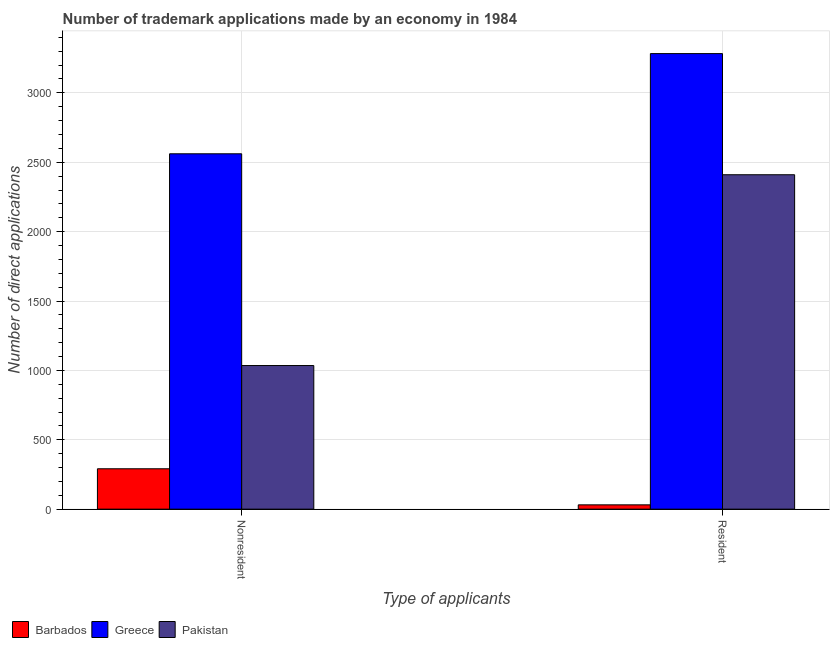How many different coloured bars are there?
Your answer should be compact. 3. Are the number of bars on each tick of the X-axis equal?
Your answer should be compact. Yes. How many bars are there on the 2nd tick from the left?
Give a very brief answer. 3. What is the label of the 2nd group of bars from the left?
Your answer should be very brief. Resident. What is the number of trademark applications made by non residents in Barbados?
Offer a terse response. 291. Across all countries, what is the maximum number of trademark applications made by non residents?
Offer a terse response. 2561. Across all countries, what is the minimum number of trademark applications made by residents?
Provide a short and direct response. 31. In which country was the number of trademark applications made by residents minimum?
Offer a very short reply. Barbados. What is the total number of trademark applications made by residents in the graph?
Make the answer very short. 5724. What is the difference between the number of trademark applications made by non residents in Greece and that in Pakistan?
Make the answer very short. 1526. What is the difference between the number of trademark applications made by non residents in Pakistan and the number of trademark applications made by residents in Greece?
Your answer should be very brief. -2248. What is the average number of trademark applications made by residents per country?
Your answer should be compact. 1908. What is the difference between the number of trademark applications made by non residents and number of trademark applications made by residents in Greece?
Offer a very short reply. -722. In how many countries, is the number of trademark applications made by non residents greater than 1400 ?
Keep it short and to the point. 1. What is the ratio of the number of trademark applications made by residents in Greece to that in Pakistan?
Provide a succinct answer. 1.36. In how many countries, is the number of trademark applications made by residents greater than the average number of trademark applications made by residents taken over all countries?
Ensure brevity in your answer.  2. What does the 3rd bar from the right in Nonresident represents?
Make the answer very short. Barbados. How many countries are there in the graph?
Provide a short and direct response. 3. What is the difference between two consecutive major ticks on the Y-axis?
Offer a very short reply. 500. How are the legend labels stacked?
Make the answer very short. Horizontal. What is the title of the graph?
Your response must be concise. Number of trademark applications made by an economy in 1984. What is the label or title of the X-axis?
Your answer should be very brief. Type of applicants. What is the label or title of the Y-axis?
Ensure brevity in your answer.  Number of direct applications. What is the Number of direct applications of Barbados in Nonresident?
Give a very brief answer. 291. What is the Number of direct applications in Greece in Nonresident?
Your answer should be compact. 2561. What is the Number of direct applications in Pakistan in Nonresident?
Keep it short and to the point. 1035. What is the Number of direct applications of Barbados in Resident?
Give a very brief answer. 31. What is the Number of direct applications of Greece in Resident?
Your answer should be very brief. 3283. What is the Number of direct applications of Pakistan in Resident?
Give a very brief answer. 2410. Across all Type of applicants, what is the maximum Number of direct applications in Barbados?
Offer a very short reply. 291. Across all Type of applicants, what is the maximum Number of direct applications of Greece?
Provide a short and direct response. 3283. Across all Type of applicants, what is the maximum Number of direct applications of Pakistan?
Your answer should be very brief. 2410. Across all Type of applicants, what is the minimum Number of direct applications of Greece?
Your answer should be very brief. 2561. Across all Type of applicants, what is the minimum Number of direct applications in Pakistan?
Make the answer very short. 1035. What is the total Number of direct applications of Barbados in the graph?
Your answer should be very brief. 322. What is the total Number of direct applications of Greece in the graph?
Your answer should be very brief. 5844. What is the total Number of direct applications in Pakistan in the graph?
Keep it short and to the point. 3445. What is the difference between the Number of direct applications in Barbados in Nonresident and that in Resident?
Provide a succinct answer. 260. What is the difference between the Number of direct applications of Greece in Nonresident and that in Resident?
Offer a very short reply. -722. What is the difference between the Number of direct applications in Pakistan in Nonresident and that in Resident?
Provide a succinct answer. -1375. What is the difference between the Number of direct applications of Barbados in Nonresident and the Number of direct applications of Greece in Resident?
Offer a terse response. -2992. What is the difference between the Number of direct applications in Barbados in Nonresident and the Number of direct applications in Pakistan in Resident?
Your response must be concise. -2119. What is the difference between the Number of direct applications in Greece in Nonresident and the Number of direct applications in Pakistan in Resident?
Ensure brevity in your answer.  151. What is the average Number of direct applications in Barbados per Type of applicants?
Ensure brevity in your answer.  161. What is the average Number of direct applications in Greece per Type of applicants?
Give a very brief answer. 2922. What is the average Number of direct applications in Pakistan per Type of applicants?
Offer a very short reply. 1722.5. What is the difference between the Number of direct applications in Barbados and Number of direct applications in Greece in Nonresident?
Give a very brief answer. -2270. What is the difference between the Number of direct applications in Barbados and Number of direct applications in Pakistan in Nonresident?
Provide a succinct answer. -744. What is the difference between the Number of direct applications in Greece and Number of direct applications in Pakistan in Nonresident?
Keep it short and to the point. 1526. What is the difference between the Number of direct applications in Barbados and Number of direct applications in Greece in Resident?
Ensure brevity in your answer.  -3252. What is the difference between the Number of direct applications of Barbados and Number of direct applications of Pakistan in Resident?
Make the answer very short. -2379. What is the difference between the Number of direct applications in Greece and Number of direct applications in Pakistan in Resident?
Ensure brevity in your answer.  873. What is the ratio of the Number of direct applications in Barbados in Nonresident to that in Resident?
Ensure brevity in your answer.  9.39. What is the ratio of the Number of direct applications in Greece in Nonresident to that in Resident?
Offer a very short reply. 0.78. What is the ratio of the Number of direct applications of Pakistan in Nonresident to that in Resident?
Give a very brief answer. 0.43. What is the difference between the highest and the second highest Number of direct applications of Barbados?
Keep it short and to the point. 260. What is the difference between the highest and the second highest Number of direct applications in Greece?
Give a very brief answer. 722. What is the difference between the highest and the second highest Number of direct applications of Pakistan?
Provide a short and direct response. 1375. What is the difference between the highest and the lowest Number of direct applications in Barbados?
Make the answer very short. 260. What is the difference between the highest and the lowest Number of direct applications in Greece?
Provide a succinct answer. 722. What is the difference between the highest and the lowest Number of direct applications of Pakistan?
Keep it short and to the point. 1375. 